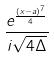Convert formula to latex. <formula><loc_0><loc_0><loc_500><loc_500>\frac { e ^ { \frac { ( x - a ) ^ { 7 } } { 4 } } } { i \sqrt { 4 \Delta } }</formula> 